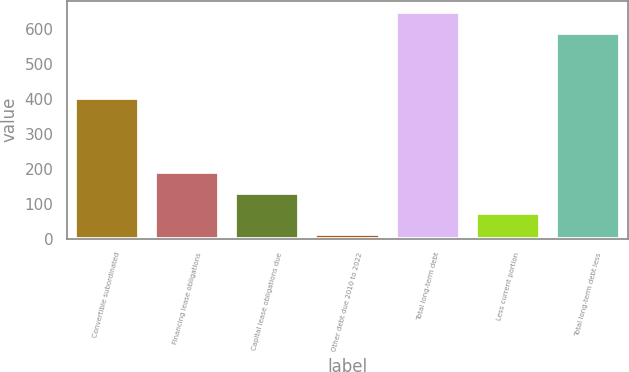<chart> <loc_0><loc_0><loc_500><loc_500><bar_chart><fcel>Convertible subordinated<fcel>Financing lease obligations<fcel>Capital lease obligations due<fcel>Other debt due 2010 to 2022<fcel>Total long-term debt<fcel>Less current portion<fcel>Total long-term debt less<nl><fcel>402<fcel>191.1<fcel>131.4<fcel>12<fcel>649.7<fcel>71.7<fcel>590<nl></chart> 